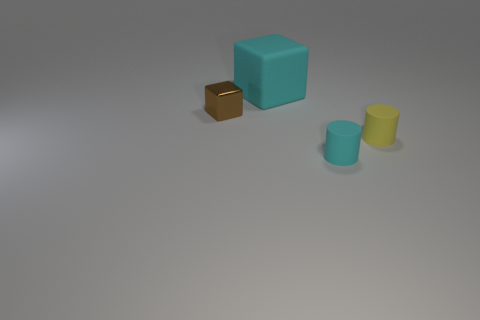Are the tiny brown thing and the large thing made of the same material?
Your answer should be very brief. No. What shape is the cyan thing that is the same material as the big block?
Provide a succinct answer. Cylinder. Are there fewer blue balls than big cyan rubber blocks?
Offer a terse response. Yes. There is a tiny object that is both to the right of the matte cube and behind the tiny cyan object; what material is it made of?
Offer a terse response. Rubber. What is the size of the thing that is in front of the small thing to the right of the cyan thing that is in front of the small metallic cube?
Provide a succinct answer. Small. There is a brown object; is it the same shape as the thing that is right of the tiny cyan matte cylinder?
Make the answer very short. No. How many rubber objects are both behind the cyan cylinder and right of the big cyan rubber block?
Give a very brief answer. 1. What number of blue things are either metal things or large matte objects?
Your answer should be compact. 0. Do the big block that is to the left of the tiny cyan cylinder and the rubber cylinder in front of the yellow thing have the same color?
Provide a short and direct response. Yes. What color is the block that is on the left side of the cyan rubber thing that is behind the object that is to the left of the large cyan matte cube?
Offer a terse response. Brown. 